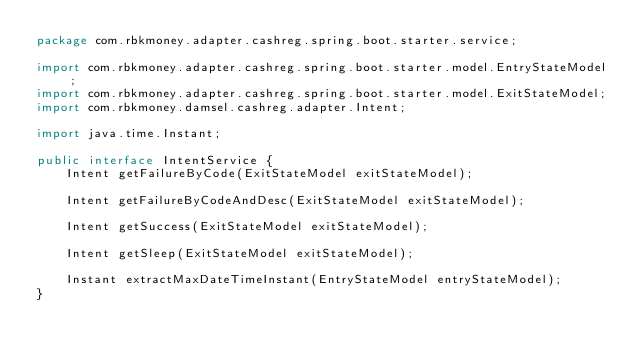Convert code to text. <code><loc_0><loc_0><loc_500><loc_500><_Java_>package com.rbkmoney.adapter.cashreg.spring.boot.starter.service;

import com.rbkmoney.adapter.cashreg.spring.boot.starter.model.EntryStateModel;
import com.rbkmoney.adapter.cashreg.spring.boot.starter.model.ExitStateModel;
import com.rbkmoney.damsel.cashreg.adapter.Intent;

import java.time.Instant;

public interface IntentService {
    Intent getFailureByCode(ExitStateModel exitStateModel);

    Intent getFailureByCodeAndDesc(ExitStateModel exitStateModel);

    Intent getSuccess(ExitStateModel exitStateModel);

    Intent getSleep(ExitStateModel exitStateModel);

    Instant extractMaxDateTimeInstant(EntryStateModel entryStateModel);
}
</code> 